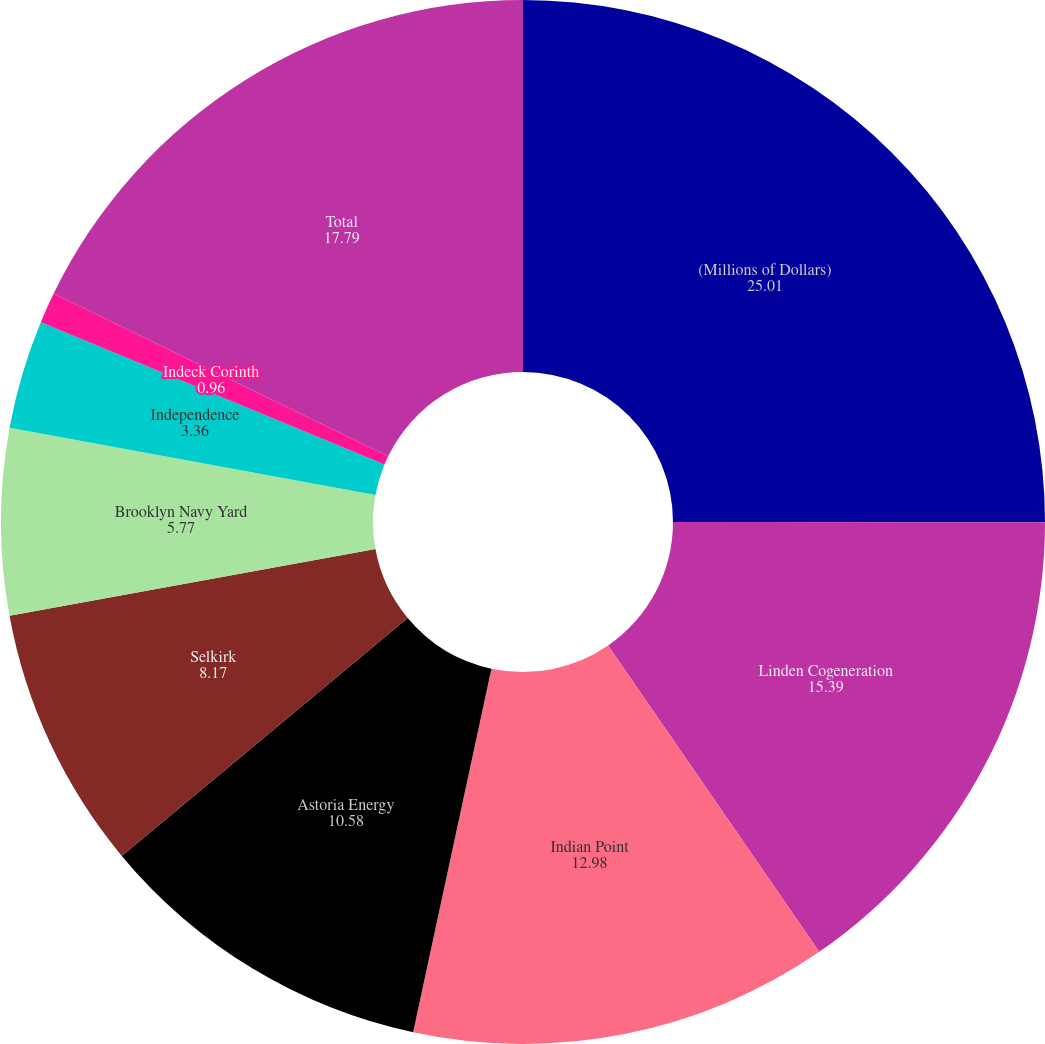Convert chart. <chart><loc_0><loc_0><loc_500><loc_500><pie_chart><fcel>(Millions of Dollars)<fcel>Linden Cogeneration<fcel>Indian Point<fcel>Astoria Energy<fcel>Selkirk<fcel>Brooklyn Navy Yard<fcel>Independence<fcel>Indeck Corinth<fcel>Total<nl><fcel>25.01%<fcel>15.39%<fcel>12.98%<fcel>10.58%<fcel>8.17%<fcel>5.77%<fcel>3.36%<fcel>0.96%<fcel>17.79%<nl></chart> 